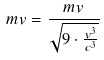<formula> <loc_0><loc_0><loc_500><loc_500>m v = \frac { m v } { \sqrt { 9 \cdot \frac { v ^ { 3 } } { c ^ { 3 } } } }</formula> 